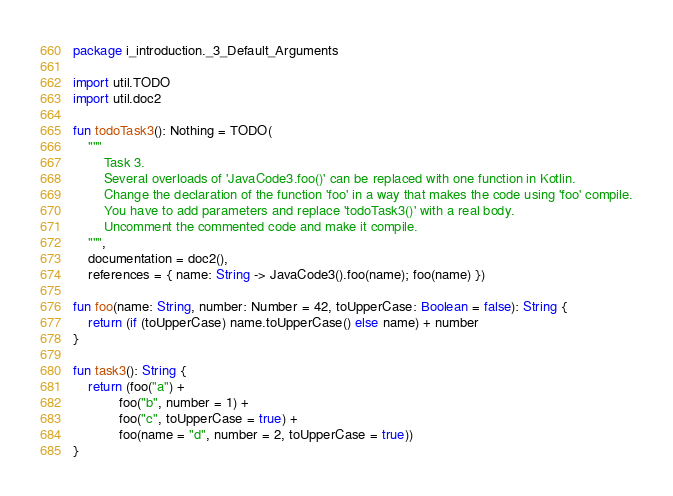Convert code to text. <code><loc_0><loc_0><loc_500><loc_500><_Kotlin_>package i_introduction._3_Default_Arguments

import util.TODO
import util.doc2

fun todoTask3(): Nothing = TODO(
    """
        Task 3.
        Several overloads of 'JavaCode3.foo()' can be replaced with one function in Kotlin.
        Change the declaration of the function 'foo' in a way that makes the code using 'foo' compile.
        You have to add parameters and replace 'todoTask3()' with a real body.
        Uncomment the commented code and make it compile.
    """,
    documentation = doc2(),
    references = { name: String -> JavaCode3().foo(name); foo(name) })

fun foo(name: String, number: Number = 42, toUpperCase: Boolean = false): String {
    return (if (toUpperCase) name.toUpperCase() else name) + number
}

fun task3(): String {
    return (foo("a") +
            foo("b", number = 1) +
            foo("c", toUpperCase = true) +
            foo(name = "d", number = 2, toUpperCase = true))
}
</code> 